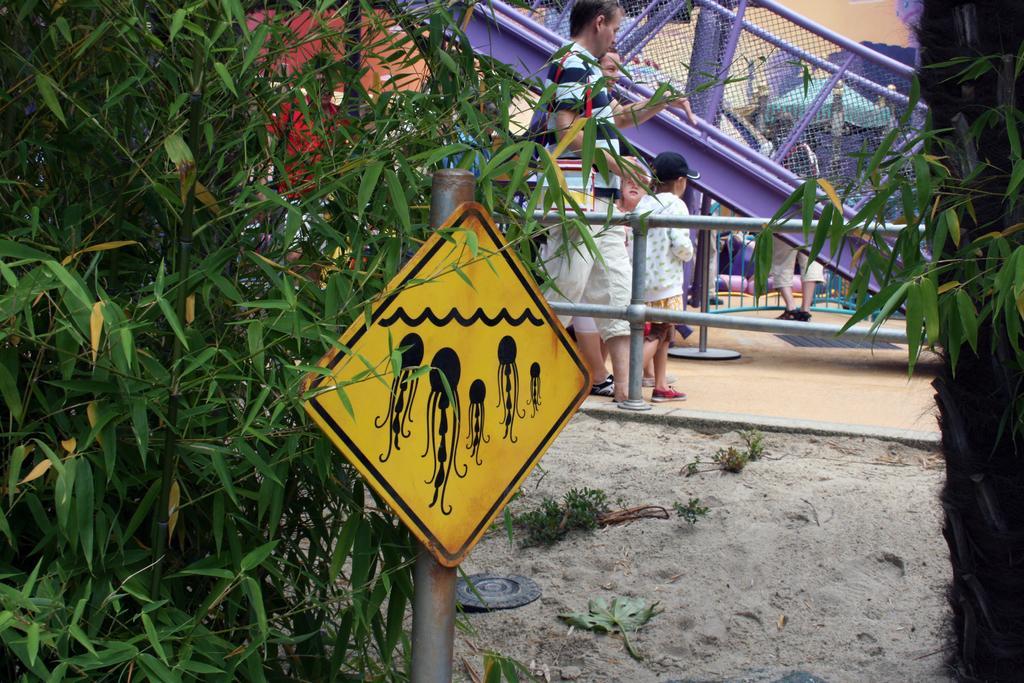Describe this image in one or two sentences. In this picture I can see people standing on the ground. On the left side I can see a yellow color sign board and trees. In the background I can see fence and other objects. 